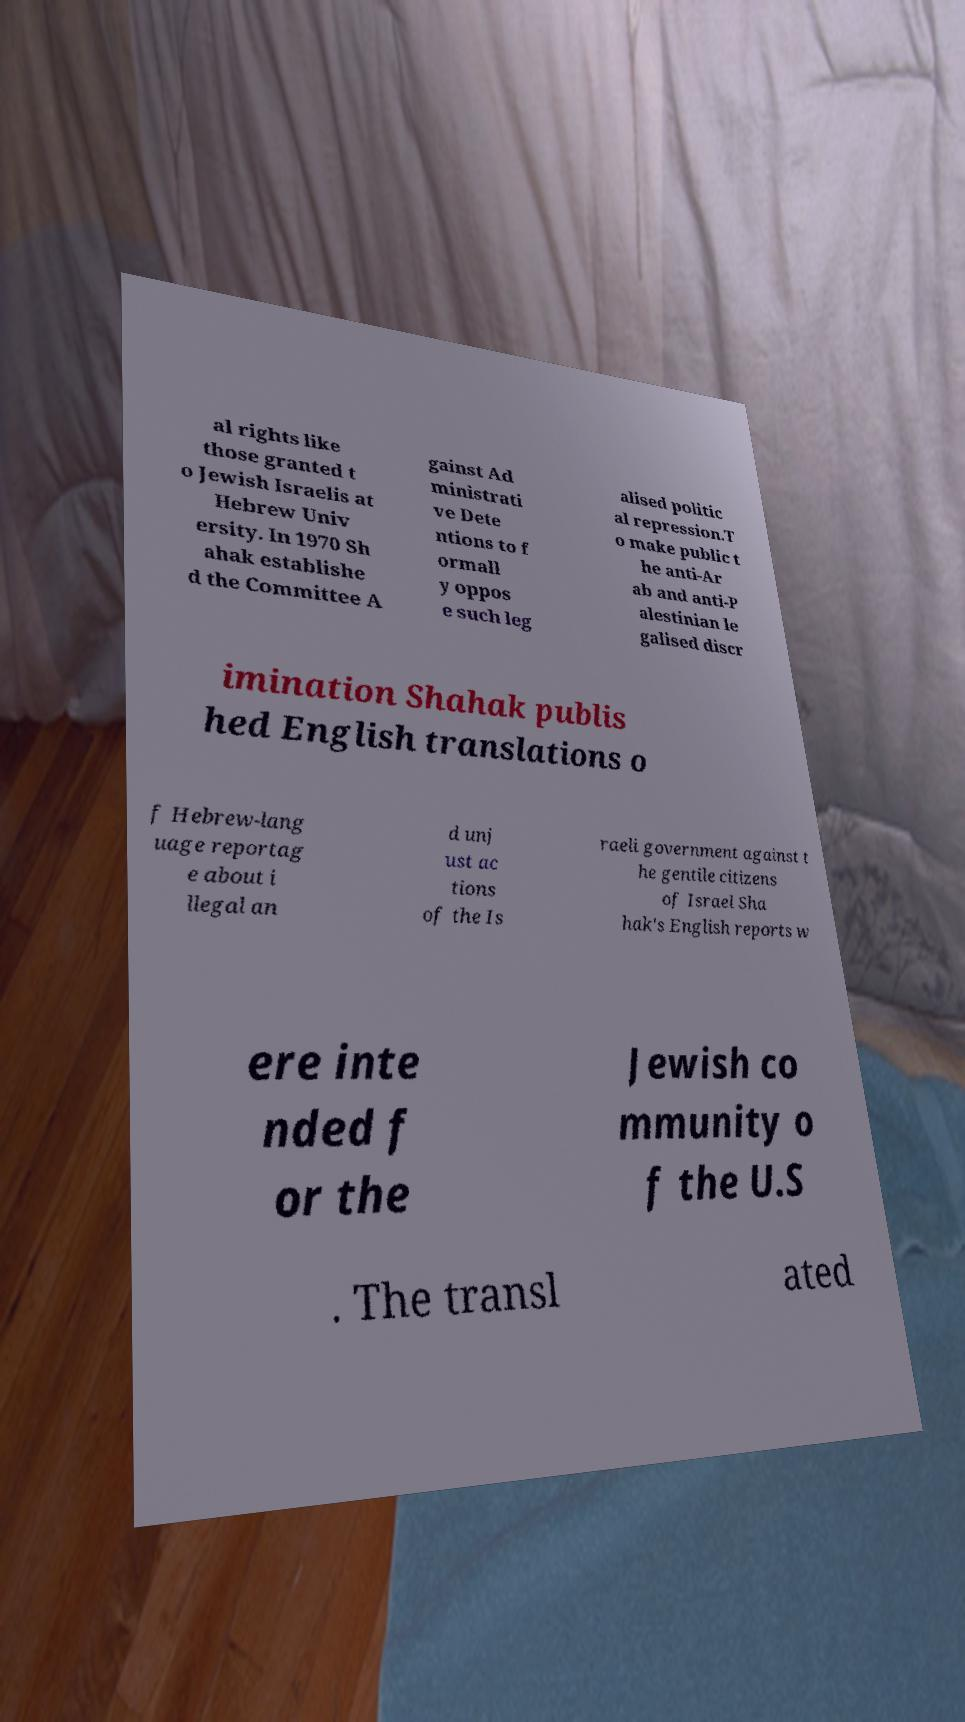Can you read and provide the text displayed in the image?This photo seems to have some interesting text. Can you extract and type it out for me? al rights like those granted t o Jewish Israelis at Hebrew Univ ersity. In 1970 Sh ahak establishe d the Committee A gainst Ad ministrati ve Dete ntions to f ormall y oppos e such leg alised politic al repression.T o make public t he anti-Ar ab and anti-P alestinian le galised discr imination Shahak publis hed English translations o f Hebrew-lang uage reportag e about i llegal an d unj ust ac tions of the Is raeli government against t he gentile citizens of Israel Sha hak's English reports w ere inte nded f or the Jewish co mmunity o f the U.S . The transl ated 